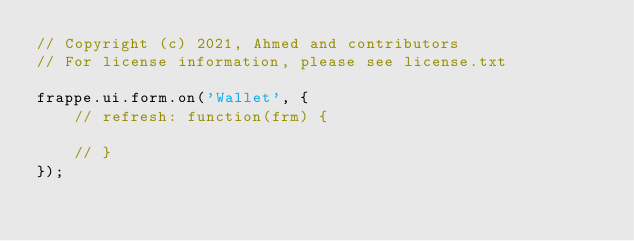<code> <loc_0><loc_0><loc_500><loc_500><_JavaScript_>// Copyright (c) 2021, Ahmed and contributors
// For license information, please see license.txt

frappe.ui.form.on('Wallet', {
	// refresh: function(frm) {

	// }
});

</code> 